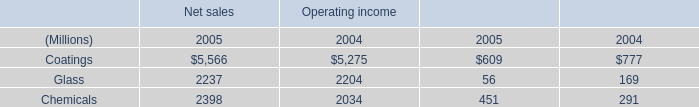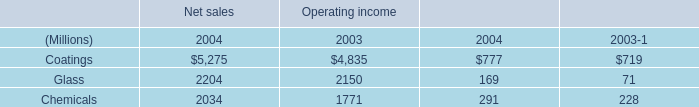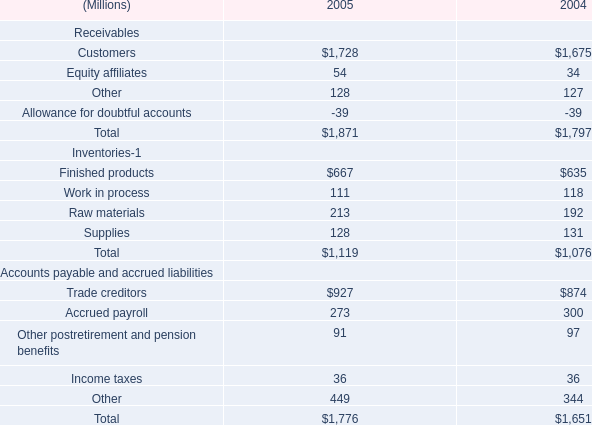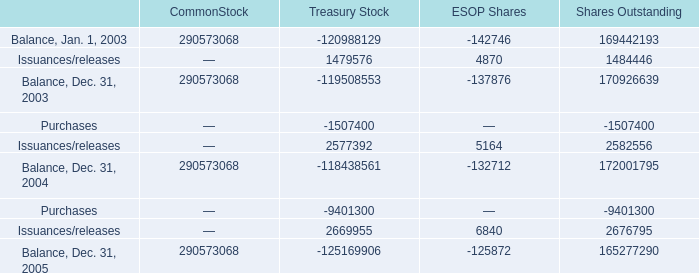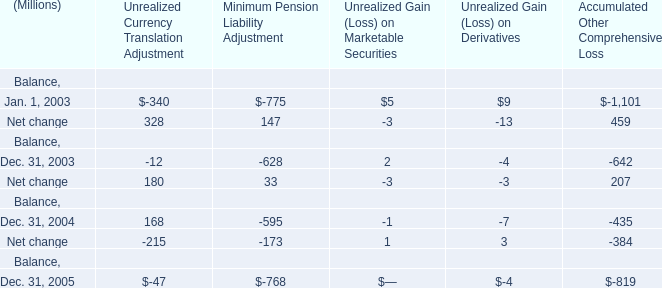In which year is Unrealized Gain (Loss) on Marketable Securities greater than 4? 
Answer: 2003. 